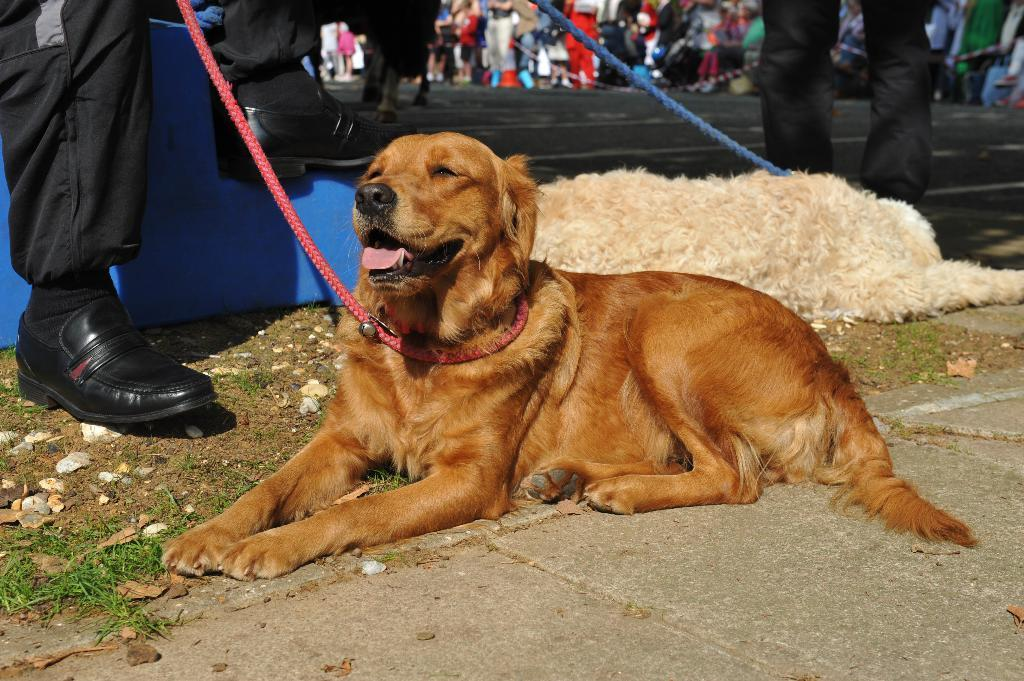What type of animals are in the image? There are dogs in the image. Who else is present in the image besides the dogs? There are people in the image. What can be seen in the background of the image? A road is visible in the image. How many snakes are slithering on the road in the image? There are no snakes present in the image; it features dogs and people. What type of punishment is being administered to the dogs in the image? There is no punishment being administered to the dogs in the image; they are simply present with people. 